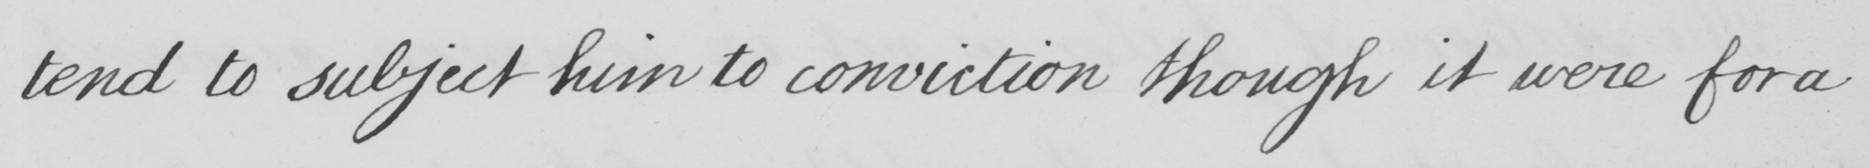What is written in this line of handwriting? tend to subject him to conviction though it were for a 